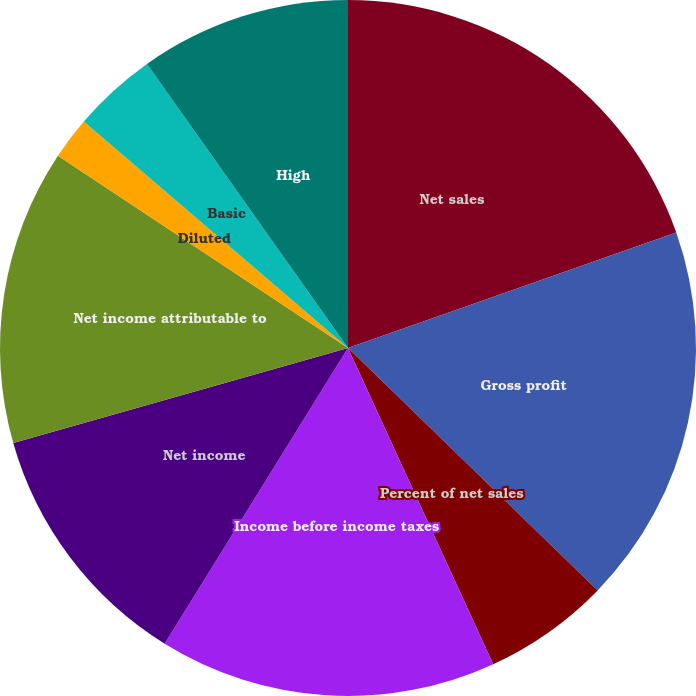<chart> <loc_0><loc_0><loc_500><loc_500><pie_chart><fcel>Net sales<fcel>Gross profit<fcel>Percent of net sales<fcel>Income before income taxes<fcel>Net income<fcel>Net income attributable to<fcel>Diluted<fcel>Basic<fcel>Cash dividends declared per<fcel>High<nl><fcel>19.61%<fcel>17.65%<fcel>5.88%<fcel>15.68%<fcel>11.76%<fcel>13.72%<fcel>1.96%<fcel>3.92%<fcel>0.0%<fcel>9.8%<nl></chart> 